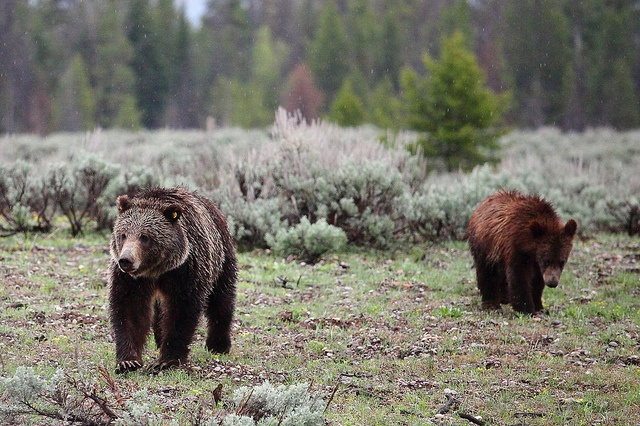Describe the objects in this image and their specific colors. I can see bear in gray, black, and darkgray tones and bear in gray, black, maroon, and brown tones in this image. 